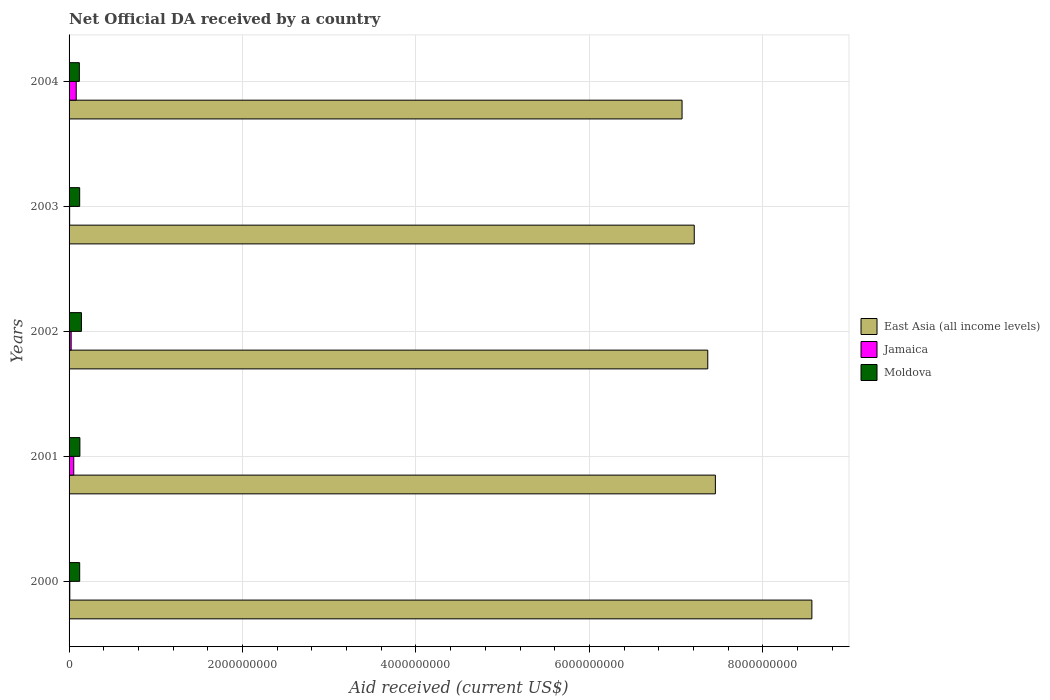How many different coloured bars are there?
Ensure brevity in your answer.  3. How many groups of bars are there?
Provide a short and direct response. 5. Are the number of bars per tick equal to the number of legend labels?
Your answer should be compact. Yes. How many bars are there on the 4th tick from the top?
Provide a short and direct response. 3. What is the net official development assistance aid received in East Asia (all income levels) in 2002?
Your answer should be compact. 7.36e+09. Across all years, what is the maximum net official development assistance aid received in Moldova?
Keep it short and to the point. 1.43e+08. Across all years, what is the minimum net official development assistance aid received in Moldova?
Make the answer very short. 1.19e+08. What is the total net official development assistance aid received in Jamaica in the graph?
Provide a succinct answer. 1.76e+08. What is the difference between the net official development assistance aid received in East Asia (all income levels) in 2000 and that in 2003?
Provide a short and direct response. 1.36e+09. What is the difference between the net official development assistance aid received in East Asia (all income levels) in 2000 and the net official development assistance aid received in Jamaica in 2003?
Your answer should be very brief. 8.56e+09. What is the average net official development assistance aid received in Jamaica per year?
Provide a short and direct response. 3.51e+07. In the year 2003, what is the difference between the net official development assistance aid received in East Asia (all income levels) and net official development assistance aid received in Jamaica?
Your answer should be compact. 7.20e+09. What is the ratio of the net official development assistance aid received in Jamaica in 2000 to that in 2004?
Your answer should be compact. 0.1. Is the net official development assistance aid received in East Asia (all income levels) in 2002 less than that in 2004?
Offer a terse response. No. Is the difference between the net official development assistance aid received in East Asia (all income levels) in 2000 and 2004 greater than the difference between the net official development assistance aid received in Jamaica in 2000 and 2004?
Ensure brevity in your answer.  Yes. What is the difference between the highest and the second highest net official development assistance aid received in Moldova?
Your answer should be very brief. 1.78e+07. What is the difference between the highest and the lowest net official development assistance aid received in Jamaica?
Your answer should be compact. 7.61e+07. In how many years, is the net official development assistance aid received in Jamaica greater than the average net official development assistance aid received in Jamaica taken over all years?
Ensure brevity in your answer.  2. What does the 1st bar from the top in 2001 represents?
Give a very brief answer. Moldova. What does the 3rd bar from the bottom in 2003 represents?
Offer a terse response. Moldova. Is it the case that in every year, the sum of the net official development assistance aid received in Moldova and net official development assistance aid received in Jamaica is greater than the net official development assistance aid received in East Asia (all income levels)?
Offer a very short reply. No. Are all the bars in the graph horizontal?
Provide a succinct answer. Yes. How many years are there in the graph?
Offer a terse response. 5. Does the graph contain grids?
Ensure brevity in your answer.  Yes. How many legend labels are there?
Your answer should be very brief. 3. How are the legend labels stacked?
Your answer should be very brief. Vertical. What is the title of the graph?
Ensure brevity in your answer.  Net Official DA received by a country. What is the label or title of the X-axis?
Ensure brevity in your answer.  Aid received (current US$). What is the label or title of the Y-axis?
Give a very brief answer. Years. What is the Aid received (current US$) in East Asia (all income levels) in 2000?
Your response must be concise. 8.57e+09. What is the Aid received (current US$) in Jamaica in 2000?
Provide a short and direct response. 8.56e+06. What is the Aid received (current US$) in Moldova in 2000?
Make the answer very short. 1.22e+08. What is the Aid received (current US$) in East Asia (all income levels) in 2001?
Your answer should be very brief. 7.45e+09. What is the Aid received (current US$) in Jamaica in 2001?
Your response must be concise. 5.40e+07. What is the Aid received (current US$) of Moldova in 2001?
Keep it short and to the point. 1.25e+08. What is the Aid received (current US$) in East Asia (all income levels) in 2002?
Ensure brevity in your answer.  7.36e+09. What is the Aid received (current US$) of Jamaica in 2002?
Your response must be concise. 2.40e+07. What is the Aid received (current US$) in Moldova in 2002?
Your answer should be very brief. 1.43e+08. What is the Aid received (current US$) of East Asia (all income levels) in 2003?
Ensure brevity in your answer.  7.21e+09. What is the Aid received (current US$) of Jamaica in 2003?
Provide a short and direct response. 6.52e+06. What is the Aid received (current US$) of Moldova in 2003?
Your answer should be compact. 1.22e+08. What is the Aid received (current US$) in East Asia (all income levels) in 2004?
Provide a short and direct response. 7.07e+09. What is the Aid received (current US$) of Jamaica in 2004?
Offer a very short reply. 8.26e+07. What is the Aid received (current US$) in Moldova in 2004?
Your response must be concise. 1.19e+08. Across all years, what is the maximum Aid received (current US$) in East Asia (all income levels)?
Give a very brief answer. 8.57e+09. Across all years, what is the maximum Aid received (current US$) in Jamaica?
Keep it short and to the point. 8.26e+07. Across all years, what is the maximum Aid received (current US$) in Moldova?
Offer a very short reply. 1.43e+08. Across all years, what is the minimum Aid received (current US$) in East Asia (all income levels)?
Offer a terse response. 7.07e+09. Across all years, what is the minimum Aid received (current US$) of Jamaica?
Make the answer very short. 6.52e+06. Across all years, what is the minimum Aid received (current US$) of Moldova?
Your response must be concise. 1.19e+08. What is the total Aid received (current US$) of East Asia (all income levels) in the graph?
Keep it short and to the point. 3.77e+1. What is the total Aid received (current US$) in Jamaica in the graph?
Give a very brief answer. 1.76e+08. What is the total Aid received (current US$) in Moldova in the graph?
Give a very brief answer. 6.31e+08. What is the difference between the Aid received (current US$) of East Asia (all income levels) in 2000 and that in 2001?
Make the answer very short. 1.11e+09. What is the difference between the Aid received (current US$) of Jamaica in 2000 and that in 2001?
Ensure brevity in your answer.  -4.54e+07. What is the difference between the Aid received (current US$) in Moldova in 2000 and that in 2001?
Your answer should be compact. -2.26e+06. What is the difference between the Aid received (current US$) of East Asia (all income levels) in 2000 and that in 2002?
Provide a succinct answer. 1.20e+09. What is the difference between the Aid received (current US$) of Jamaica in 2000 and that in 2002?
Your answer should be very brief. -1.55e+07. What is the difference between the Aid received (current US$) of Moldova in 2000 and that in 2002?
Your response must be concise. -2.01e+07. What is the difference between the Aid received (current US$) in East Asia (all income levels) in 2000 and that in 2003?
Keep it short and to the point. 1.36e+09. What is the difference between the Aid received (current US$) in Jamaica in 2000 and that in 2003?
Your answer should be compact. 2.04e+06. What is the difference between the Aid received (current US$) in East Asia (all income levels) in 2000 and that in 2004?
Keep it short and to the point. 1.50e+09. What is the difference between the Aid received (current US$) of Jamaica in 2000 and that in 2004?
Offer a very short reply. -7.41e+07. What is the difference between the Aid received (current US$) in Moldova in 2000 and that in 2004?
Your response must be concise. 3.99e+06. What is the difference between the Aid received (current US$) of East Asia (all income levels) in 2001 and that in 2002?
Ensure brevity in your answer.  8.78e+07. What is the difference between the Aid received (current US$) in Jamaica in 2001 and that in 2002?
Provide a succinct answer. 3.00e+07. What is the difference between the Aid received (current US$) of Moldova in 2001 and that in 2002?
Your response must be concise. -1.78e+07. What is the difference between the Aid received (current US$) of East Asia (all income levels) in 2001 and that in 2003?
Your answer should be compact. 2.44e+08. What is the difference between the Aid received (current US$) in Jamaica in 2001 and that in 2003?
Your answer should be very brief. 4.75e+07. What is the difference between the Aid received (current US$) in Moldova in 2001 and that in 2003?
Make the answer very short. 2.46e+06. What is the difference between the Aid received (current US$) in East Asia (all income levels) in 2001 and that in 2004?
Offer a very short reply. 3.84e+08. What is the difference between the Aid received (current US$) in Jamaica in 2001 and that in 2004?
Your answer should be very brief. -2.86e+07. What is the difference between the Aid received (current US$) of Moldova in 2001 and that in 2004?
Your response must be concise. 6.25e+06. What is the difference between the Aid received (current US$) in East Asia (all income levels) in 2002 and that in 2003?
Ensure brevity in your answer.  1.56e+08. What is the difference between the Aid received (current US$) of Jamaica in 2002 and that in 2003?
Make the answer very short. 1.75e+07. What is the difference between the Aid received (current US$) in Moldova in 2002 and that in 2003?
Provide a short and direct response. 2.03e+07. What is the difference between the Aid received (current US$) of East Asia (all income levels) in 2002 and that in 2004?
Your answer should be compact. 2.96e+08. What is the difference between the Aid received (current US$) of Jamaica in 2002 and that in 2004?
Give a very brief answer. -5.86e+07. What is the difference between the Aid received (current US$) in Moldova in 2002 and that in 2004?
Offer a very short reply. 2.41e+07. What is the difference between the Aid received (current US$) in East Asia (all income levels) in 2003 and that in 2004?
Your response must be concise. 1.41e+08. What is the difference between the Aid received (current US$) of Jamaica in 2003 and that in 2004?
Your answer should be compact. -7.61e+07. What is the difference between the Aid received (current US$) of Moldova in 2003 and that in 2004?
Provide a succinct answer. 3.79e+06. What is the difference between the Aid received (current US$) of East Asia (all income levels) in 2000 and the Aid received (current US$) of Jamaica in 2001?
Keep it short and to the point. 8.51e+09. What is the difference between the Aid received (current US$) in East Asia (all income levels) in 2000 and the Aid received (current US$) in Moldova in 2001?
Make the answer very short. 8.44e+09. What is the difference between the Aid received (current US$) in Jamaica in 2000 and the Aid received (current US$) in Moldova in 2001?
Provide a succinct answer. -1.16e+08. What is the difference between the Aid received (current US$) in East Asia (all income levels) in 2000 and the Aid received (current US$) in Jamaica in 2002?
Provide a succinct answer. 8.54e+09. What is the difference between the Aid received (current US$) in East Asia (all income levels) in 2000 and the Aid received (current US$) in Moldova in 2002?
Your answer should be very brief. 8.42e+09. What is the difference between the Aid received (current US$) in Jamaica in 2000 and the Aid received (current US$) in Moldova in 2002?
Ensure brevity in your answer.  -1.34e+08. What is the difference between the Aid received (current US$) of East Asia (all income levels) in 2000 and the Aid received (current US$) of Jamaica in 2003?
Offer a terse response. 8.56e+09. What is the difference between the Aid received (current US$) of East Asia (all income levels) in 2000 and the Aid received (current US$) of Moldova in 2003?
Give a very brief answer. 8.44e+09. What is the difference between the Aid received (current US$) in Jamaica in 2000 and the Aid received (current US$) in Moldova in 2003?
Make the answer very short. -1.14e+08. What is the difference between the Aid received (current US$) of East Asia (all income levels) in 2000 and the Aid received (current US$) of Jamaica in 2004?
Make the answer very short. 8.48e+09. What is the difference between the Aid received (current US$) of East Asia (all income levels) in 2000 and the Aid received (current US$) of Moldova in 2004?
Ensure brevity in your answer.  8.45e+09. What is the difference between the Aid received (current US$) of Jamaica in 2000 and the Aid received (current US$) of Moldova in 2004?
Offer a terse response. -1.10e+08. What is the difference between the Aid received (current US$) in East Asia (all income levels) in 2001 and the Aid received (current US$) in Jamaica in 2002?
Your answer should be compact. 7.43e+09. What is the difference between the Aid received (current US$) of East Asia (all income levels) in 2001 and the Aid received (current US$) of Moldova in 2002?
Offer a very short reply. 7.31e+09. What is the difference between the Aid received (current US$) of Jamaica in 2001 and the Aid received (current US$) of Moldova in 2002?
Your response must be concise. -8.86e+07. What is the difference between the Aid received (current US$) in East Asia (all income levels) in 2001 and the Aid received (current US$) in Jamaica in 2003?
Give a very brief answer. 7.45e+09. What is the difference between the Aid received (current US$) in East Asia (all income levels) in 2001 and the Aid received (current US$) in Moldova in 2003?
Provide a short and direct response. 7.33e+09. What is the difference between the Aid received (current US$) of Jamaica in 2001 and the Aid received (current US$) of Moldova in 2003?
Offer a very short reply. -6.83e+07. What is the difference between the Aid received (current US$) of East Asia (all income levels) in 2001 and the Aid received (current US$) of Jamaica in 2004?
Your answer should be very brief. 7.37e+09. What is the difference between the Aid received (current US$) in East Asia (all income levels) in 2001 and the Aid received (current US$) in Moldova in 2004?
Keep it short and to the point. 7.33e+09. What is the difference between the Aid received (current US$) of Jamaica in 2001 and the Aid received (current US$) of Moldova in 2004?
Provide a short and direct response. -6.45e+07. What is the difference between the Aid received (current US$) of East Asia (all income levels) in 2002 and the Aid received (current US$) of Jamaica in 2003?
Provide a succinct answer. 7.36e+09. What is the difference between the Aid received (current US$) in East Asia (all income levels) in 2002 and the Aid received (current US$) in Moldova in 2003?
Provide a short and direct response. 7.24e+09. What is the difference between the Aid received (current US$) of Jamaica in 2002 and the Aid received (current US$) of Moldova in 2003?
Keep it short and to the point. -9.83e+07. What is the difference between the Aid received (current US$) of East Asia (all income levels) in 2002 and the Aid received (current US$) of Jamaica in 2004?
Your answer should be very brief. 7.28e+09. What is the difference between the Aid received (current US$) of East Asia (all income levels) in 2002 and the Aid received (current US$) of Moldova in 2004?
Give a very brief answer. 7.25e+09. What is the difference between the Aid received (current US$) of Jamaica in 2002 and the Aid received (current US$) of Moldova in 2004?
Provide a short and direct response. -9.45e+07. What is the difference between the Aid received (current US$) in East Asia (all income levels) in 2003 and the Aid received (current US$) in Jamaica in 2004?
Provide a short and direct response. 7.13e+09. What is the difference between the Aid received (current US$) of East Asia (all income levels) in 2003 and the Aid received (current US$) of Moldova in 2004?
Keep it short and to the point. 7.09e+09. What is the difference between the Aid received (current US$) of Jamaica in 2003 and the Aid received (current US$) of Moldova in 2004?
Provide a succinct answer. -1.12e+08. What is the average Aid received (current US$) in East Asia (all income levels) per year?
Your answer should be very brief. 7.53e+09. What is the average Aid received (current US$) of Jamaica per year?
Offer a very short reply. 3.51e+07. What is the average Aid received (current US$) of Moldova per year?
Provide a succinct answer. 1.26e+08. In the year 2000, what is the difference between the Aid received (current US$) in East Asia (all income levels) and Aid received (current US$) in Jamaica?
Provide a succinct answer. 8.56e+09. In the year 2000, what is the difference between the Aid received (current US$) in East Asia (all income levels) and Aid received (current US$) in Moldova?
Your response must be concise. 8.44e+09. In the year 2000, what is the difference between the Aid received (current US$) of Jamaica and Aid received (current US$) of Moldova?
Your answer should be compact. -1.14e+08. In the year 2001, what is the difference between the Aid received (current US$) in East Asia (all income levels) and Aid received (current US$) in Jamaica?
Offer a very short reply. 7.40e+09. In the year 2001, what is the difference between the Aid received (current US$) in East Asia (all income levels) and Aid received (current US$) in Moldova?
Make the answer very short. 7.33e+09. In the year 2001, what is the difference between the Aid received (current US$) in Jamaica and Aid received (current US$) in Moldova?
Your answer should be very brief. -7.08e+07. In the year 2002, what is the difference between the Aid received (current US$) of East Asia (all income levels) and Aid received (current US$) of Jamaica?
Provide a short and direct response. 7.34e+09. In the year 2002, what is the difference between the Aid received (current US$) of East Asia (all income levels) and Aid received (current US$) of Moldova?
Provide a short and direct response. 7.22e+09. In the year 2002, what is the difference between the Aid received (current US$) of Jamaica and Aid received (current US$) of Moldova?
Provide a short and direct response. -1.19e+08. In the year 2003, what is the difference between the Aid received (current US$) in East Asia (all income levels) and Aid received (current US$) in Jamaica?
Provide a succinct answer. 7.20e+09. In the year 2003, what is the difference between the Aid received (current US$) in East Asia (all income levels) and Aid received (current US$) in Moldova?
Your answer should be compact. 7.09e+09. In the year 2003, what is the difference between the Aid received (current US$) of Jamaica and Aid received (current US$) of Moldova?
Give a very brief answer. -1.16e+08. In the year 2004, what is the difference between the Aid received (current US$) in East Asia (all income levels) and Aid received (current US$) in Jamaica?
Provide a succinct answer. 6.99e+09. In the year 2004, what is the difference between the Aid received (current US$) in East Asia (all income levels) and Aid received (current US$) in Moldova?
Keep it short and to the point. 6.95e+09. In the year 2004, what is the difference between the Aid received (current US$) in Jamaica and Aid received (current US$) in Moldova?
Offer a terse response. -3.59e+07. What is the ratio of the Aid received (current US$) of East Asia (all income levels) in 2000 to that in 2001?
Offer a terse response. 1.15. What is the ratio of the Aid received (current US$) of Jamaica in 2000 to that in 2001?
Keep it short and to the point. 0.16. What is the ratio of the Aid received (current US$) in Moldova in 2000 to that in 2001?
Keep it short and to the point. 0.98. What is the ratio of the Aid received (current US$) of East Asia (all income levels) in 2000 to that in 2002?
Offer a very short reply. 1.16. What is the ratio of the Aid received (current US$) of Jamaica in 2000 to that in 2002?
Your response must be concise. 0.36. What is the ratio of the Aid received (current US$) in Moldova in 2000 to that in 2002?
Provide a short and direct response. 0.86. What is the ratio of the Aid received (current US$) of East Asia (all income levels) in 2000 to that in 2003?
Your answer should be very brief. 1.19. What is the ratio of the Aid received (current US$) of Jamaica in 2000 to that in 2003?
Your answer should be very brief. 1.31. What is the ratio of the Aid received (current US$) in East Asia (all income levels) in 2000 to that in 2004?
Offer a very short reply. 1.21. What is the ratio of the Aid received (current US$) in Jamaica in 2000 to that in 2004?
Provide a succinct answer. 0.1. What is the ratio of the Aid received (current US$) in Moldova in 2000 to that in 2004?
Offer a terse response. 1.03. What is the ratio of the Aid received (current US$) of East Asia (all income levels) in 2001 to that in 2002?
Your answer should be very brief. 1.01. What is the ratio of the Aid received (current US$) of Jamaica in 2001 to that in 2002?
Ensure brevity in your answer.  2.25. What is the ratio of the Aid received (current US$) of Moldova in 2001 to that in 2002?
Give a very brief answer. 0.87. What is the ratio of the Aid received (current US$) in East Asia (all income levels) in 2001 to that in 2003?
Provide a short and direct response. 1.03. What is the ratio of the Aid received (current US$) of Jamaica in 2001 to that in 2003?
Offer a terse response. 8.28. What is the ratio of the Aid received (current US$) of Moldova in 2001 to that in 2003?
Your answer should be compact. 1.02. What is the ratio of the Aid received (current US$) in East Asia (all income levels) in 2001 to that in 2004?
Your response must be concise. 1.05. What is the ratio of the Aid received (current US$) of Jamaica in 2001 to that in 2004?
Provide a succinct answer. 0.65. What is the ratio of the Aid received (current US$) of Moldova in 2001 to that in 2004?
Keep it short and to the point. 1.05. What is the ratio of the Aid received (current US$) in East Asia (all income levels) in 2002 to that in 2003?
Give a very brief answer. 1.02. What is the ratio of the Aid received (current US$) in Jamaica in 2002 to that in 2003?
Keep it short and to the point. 3.68. What is the ratio of the Aid received (current US$) of Moldova in 2002 to that in 2003?
Offer a terse response. 1.17. What is the ratio of the Aid received (current US$) of East Asia (all income levels) in 2002 to that in 2004?
Provide a succinct answer. 1.04. What is the ratio of the Aid received (current US$) in Jamaica in 2002 to that in 2004?
Your answer should be very brief. 0.29. What is the ratio of the Aid received (current US$) in Moldova in 2002 to that in 2004?
Keep it short and to the point. 1.2. What is the ratio of the Aid received (current US$) in East Asia (all income levels) in 2003 to that in 2004?
Keep it short and to the point. 1.02. What is the ratio of the Aid received (current US$) in Jamaica in 2003 to that in 2004?
Make the answer very short. 0.08. What is the ratio of the Aid received (current US$) in Moldova in 2003 to that in 2004?
Your answer should be very brief. 1.03. What is the difference between the highest and the second highest Aid received (current US$) of East Asia (all income levels)?
Provide a succinct answer. 1.11e+09. What is the difference between the highest and the second highest Aid received (current US$) of Jamaica?
Your answer should be compact. 2.86e+07. What is the difference between the highest and the second highest Aid received (current US$) in Moldova?
Offer a very short reply. 1.78e+07. What is the difference between the highest and the lowest Aid received (current US$) in East Asia (all income levels)?
Your answer should be compact. 1.50e+09. What is the difference between the highest and the lowest Aid received (current US$) in Jamaica?
Provide a short and direct response. 7.61e+07. What is the difference between the highest and the lowest Aid received (current US$) in Moldova?
Provide a succinct answer. 2.41e+07. 